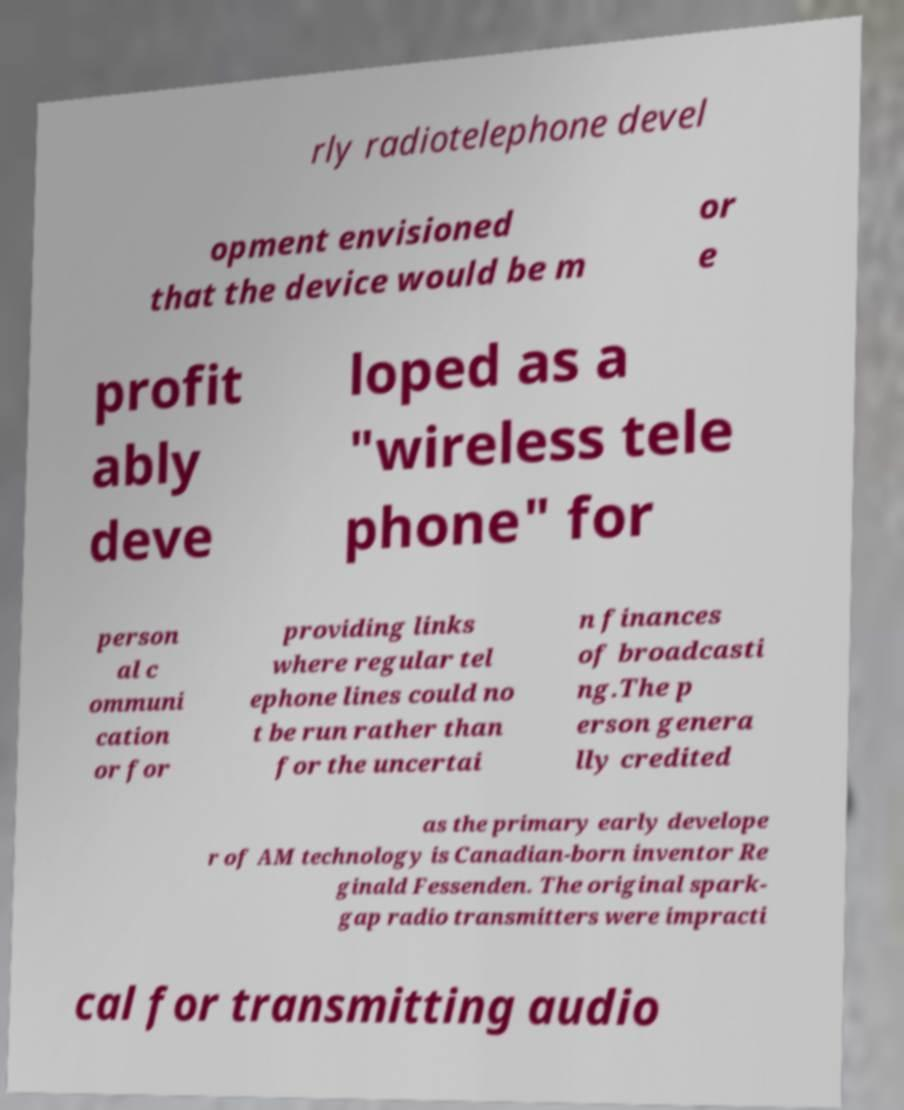I need the written content from this picture converted into text. Can you do that? rly radiotelephone devel opment envisioned that the device would be m or e profit ably deve loped as a "wireless tele phone" for person al c ommuni cation or for providing links where regular tel ephone lines could no t be run rather than for the uncertai n finances of broadcasti ng.The p erson genera lly credited as the primary early develope r of AM technology is Canadian-born inventor Re ginald Fessenden. The original spark- gap radio transmitters were impracti cal for transmitting audio 